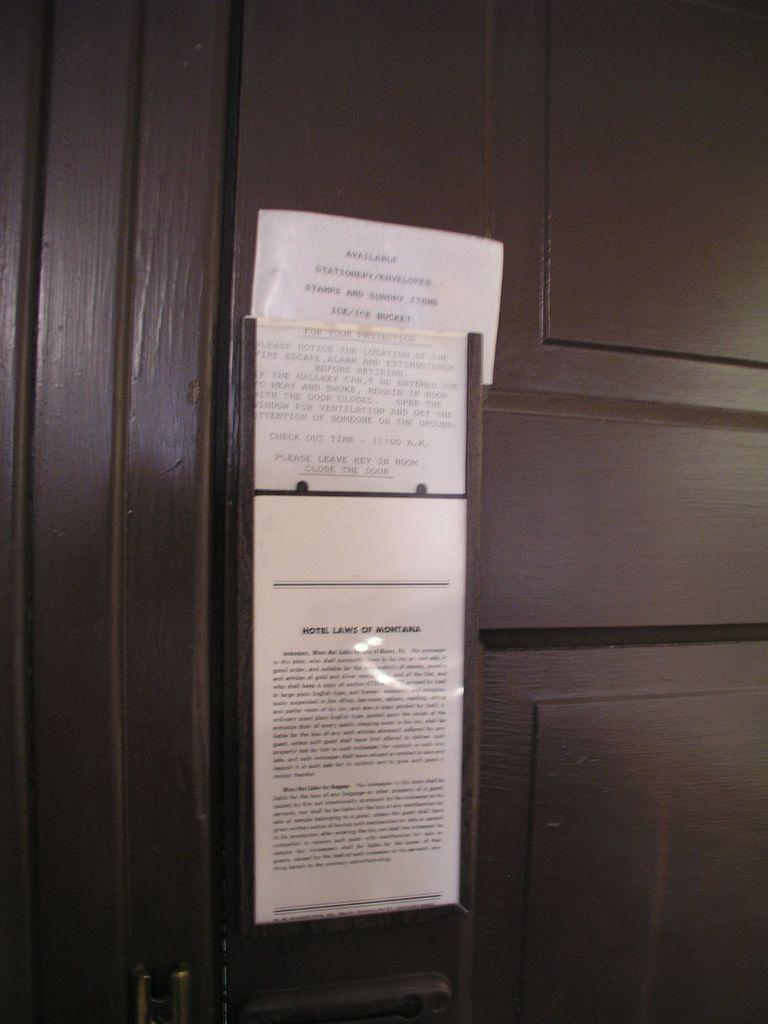Provide a one-sentence caption for the provided image. A notice that is too far away to read is posted on a dark wooden door. 